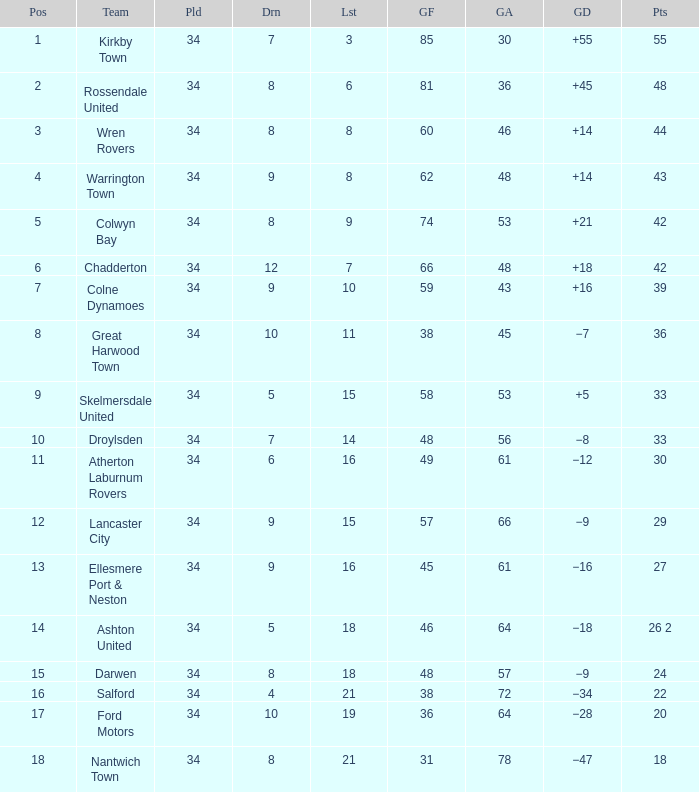What is the total number of goals for when the drawn is less than 7, less than 21 games have been lost, and there are 1 of 33 points? 1.0. 